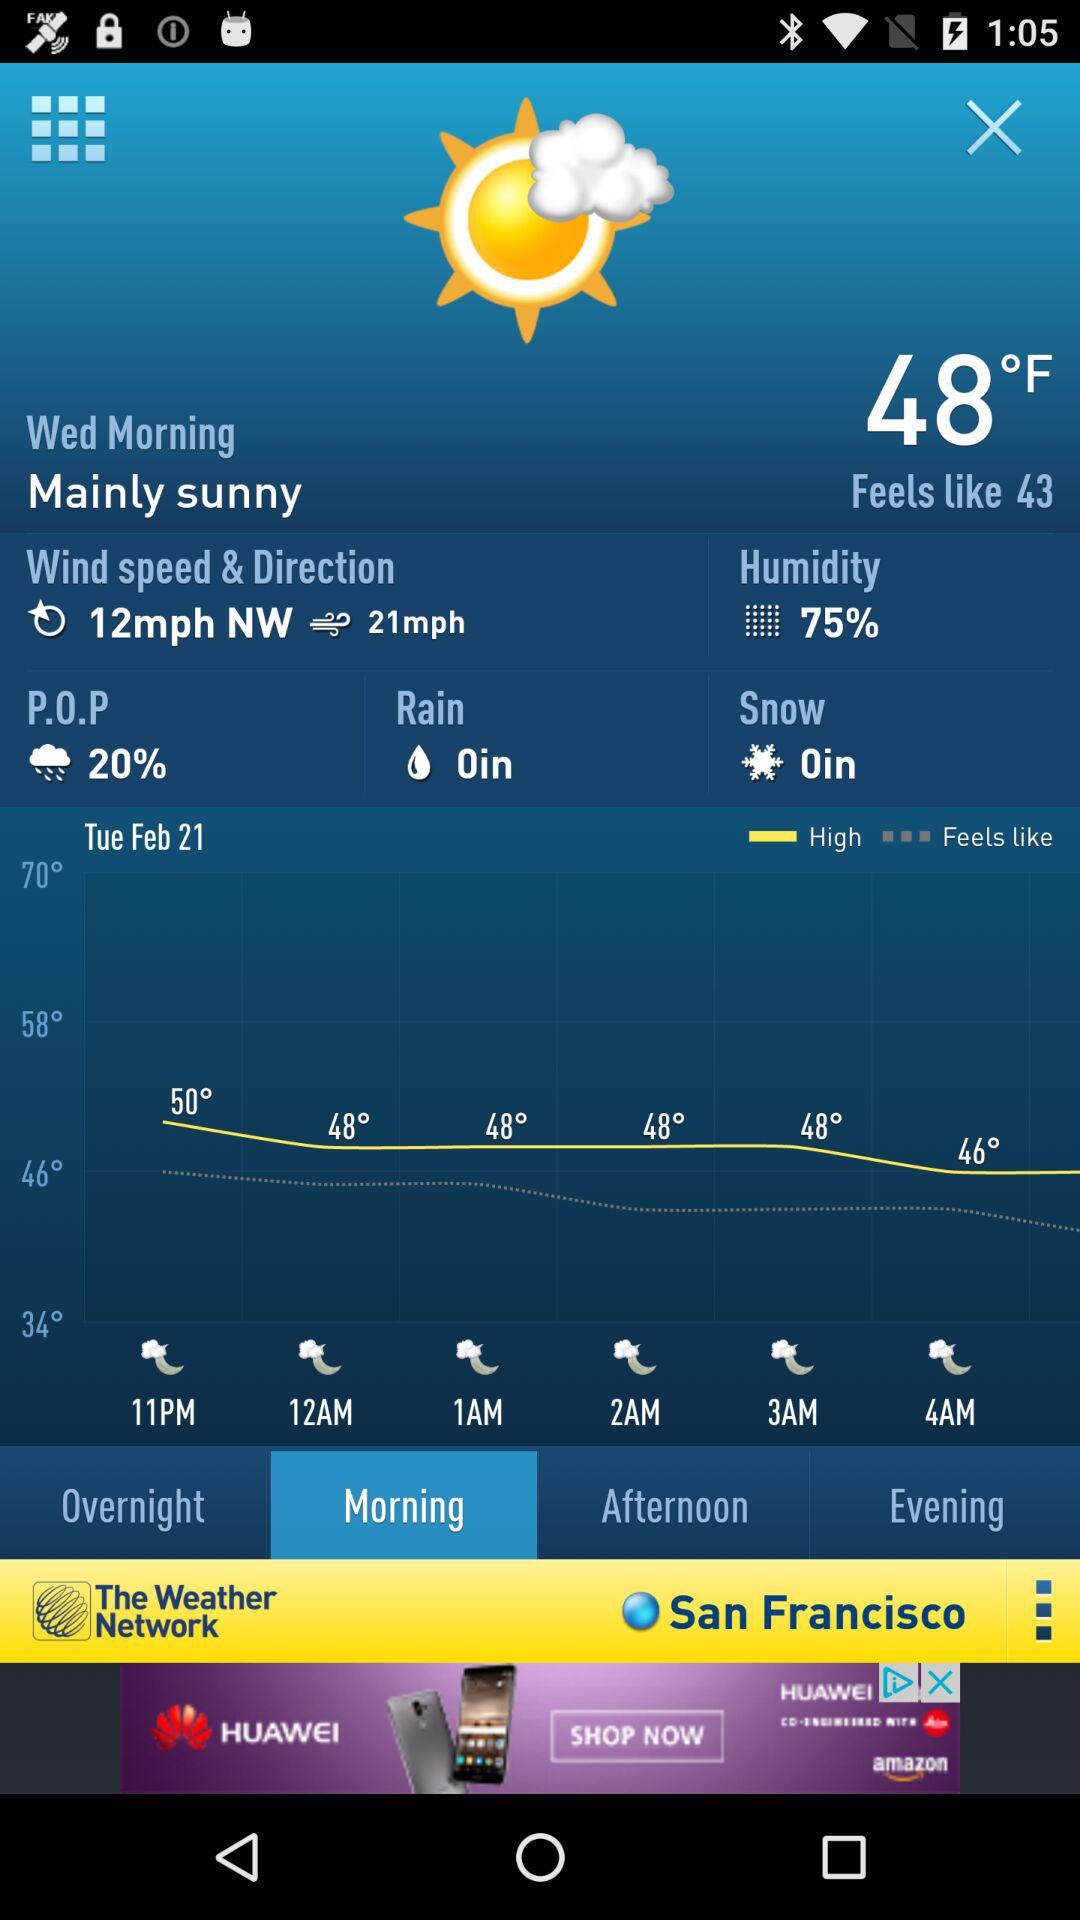What is the direction of the wind? The direction of the wind is northwest. 